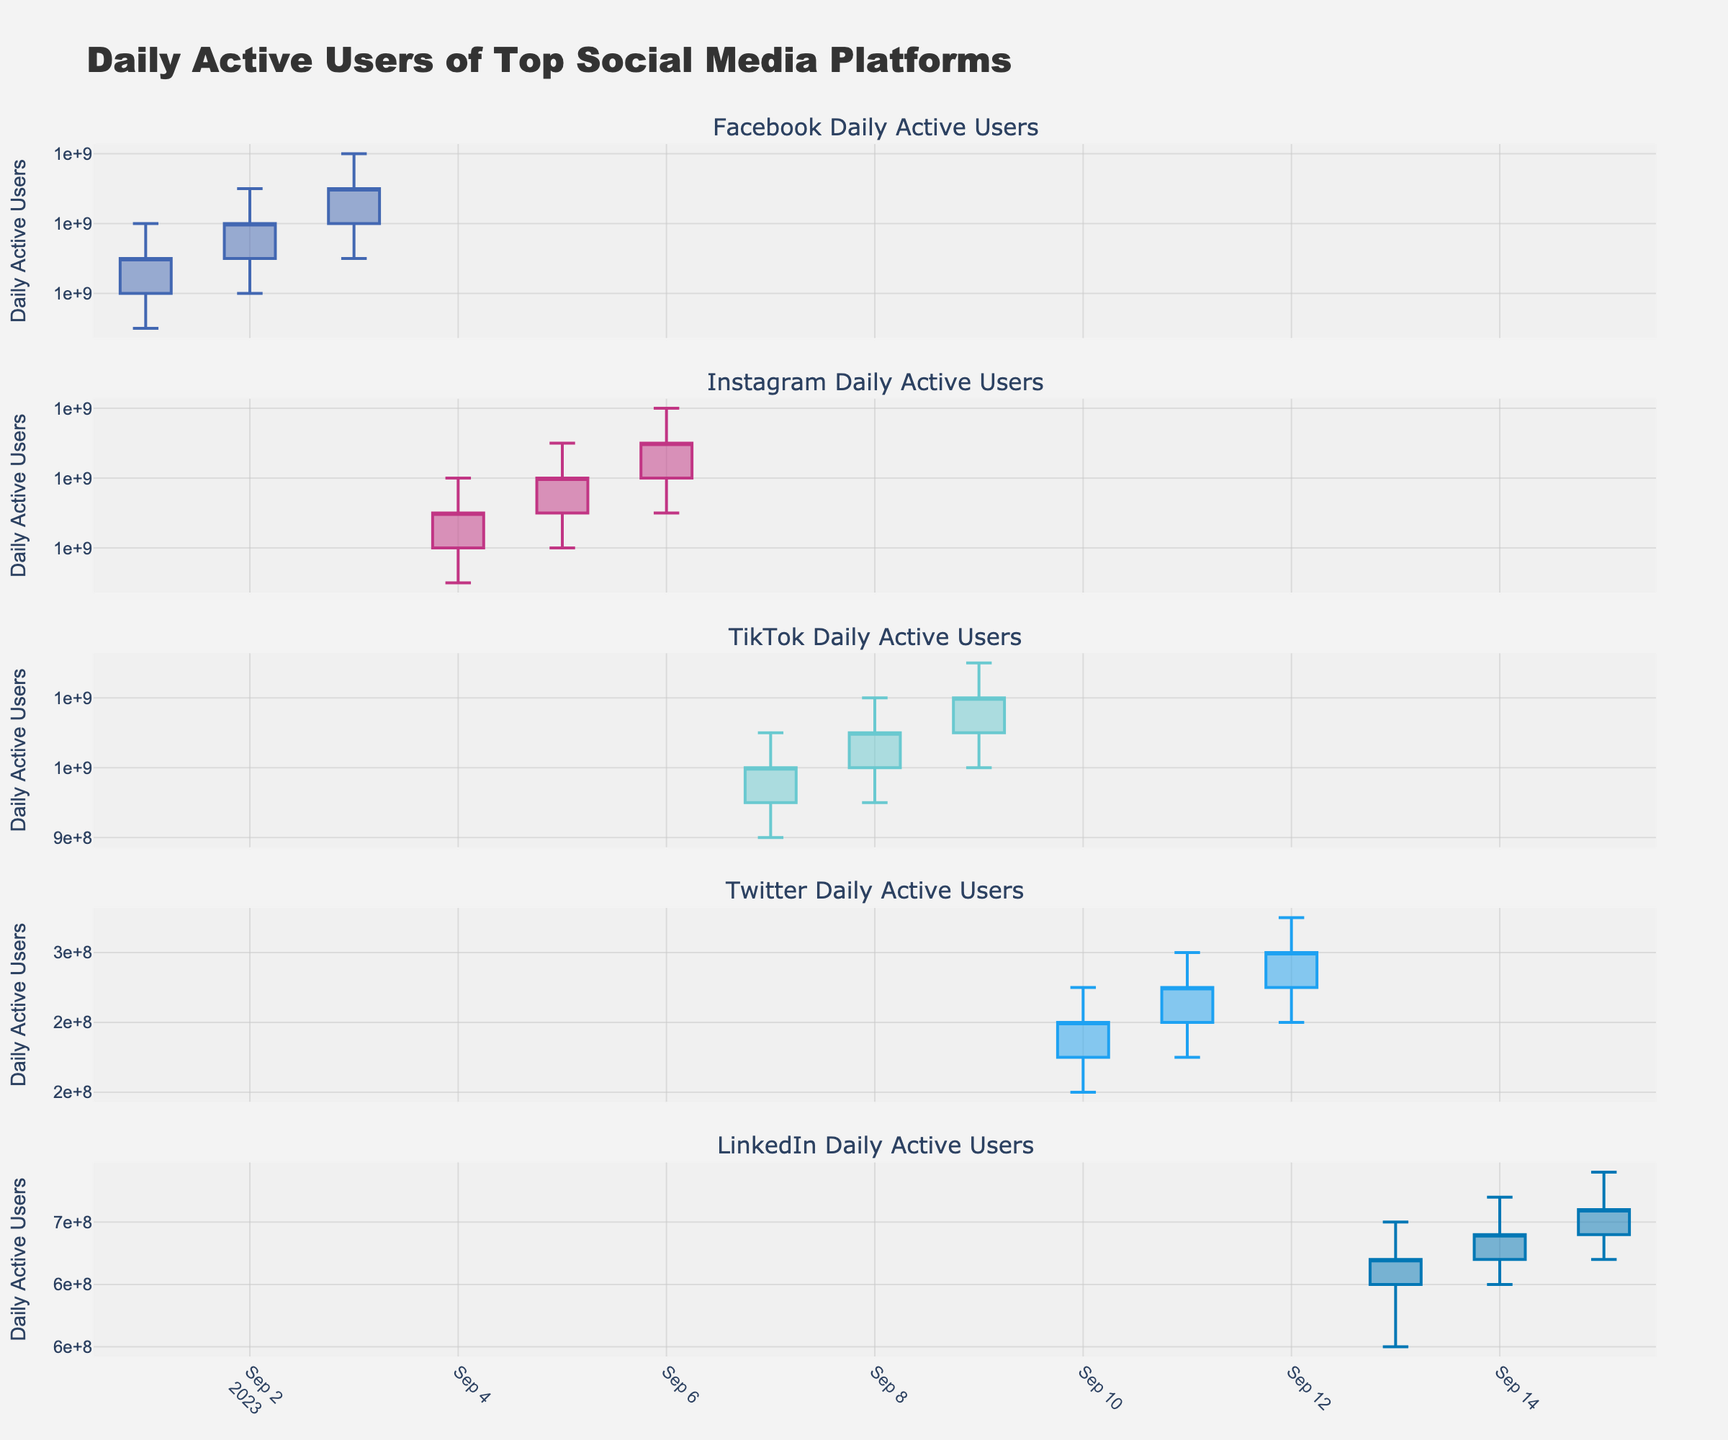what's the title of the figure? The title of the figure is displayed at the top of the plot and provides a brief description of what the plot represents.
Answer: Daily Active Users of Top Social Media Platforms What color is used to represent Instagram in the plot? The colors used to represent different platforms are specified in the plot legend or by the specific hues used for the candlesticks.
Answer: Pinkish/purple On which date does Facebook have the highest peak usage time? To find the highest peak usage time for Facebook, look for the date where the 'High' value for Facebook is the greatest. By scanning the candlestick plot for Facebook, you'll find 1400000000 on 2023-09-03.
Answer: 2023-09-03 Which platform shows the highest number of Daily Active Users at any given point within the past month? Look at all the 'High' values across all candlestick plots for different platforms. The platform with the highest peak will be the answer. By comparing maximum 'High' values, Facebook on 2023-09-03 with 1400000000 is the highest.
Answer: Facebook How does the volatility in Daily Active Users compare between TikTok and LinkedIn? Volatility can be measured by examining the range between 'High' and 'Low' values for each platform. Calculate the average range for both TikTok and LinkedIn and compare them. TikTok has larger ranges between high and low compared to LinkedIn, indicating higher volatility.
Answer: TikTok is more volatile than LinkedIn On which date did Twitter have the least Daily Active Users, and what was the lowest value? For Twitter, find the 'Low' values on each date and identify the minimum. On 2023-09-10, Twitter's 'Low' value is 220000000, which is its lowest.
Answer: 2023-09-10 with 220000000 Between 2023-09-13 and 2023-09-15, what was the total increase in the number of LinkedIn's Daily Active Users? To find the total increase, subtract the 'Open' value on 2023-09-13 from the 'Close' value on 2023-09-15 for LinkedIn. (660000000 - 600000000) = 60000000
Answer: 60000000 What is the trend in Daily Active Users for Instagram from 2023-09-04 to 2023-09-06? To identify the trend, examine the 'Open' and 'Close' values for Instagram from 2023-09-04 to 2023-09-06. The values increase each day, indicating an upward trend.
Answer: Upward trend Which platform has the most consistent number of Daily Active Users, and how can you tell? Consistency is indicated by smaller ranges between 'Open', 'High', 'Low', and 'Close'. Twitter has the smallest variation in these values, indicating it has the most consistent user count.
Answer: Twitter If the average number of Daily Active Users for TikTok from 2023-09-07 to 2023-09-09 is needed, how do you calculate it? Sum the 'Close' values for TikTok from 2023-09-07 to 2023-09-09 and divide by the number of days. (1000000000 + 1050000000 + 1100000000) / 3 = 1050000000
Answer: 1050000000 